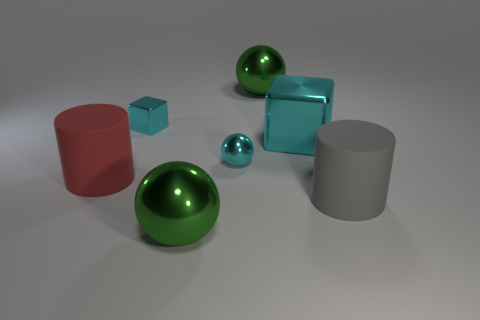What is the material of the large red object that is the same shape as the big gray rubber thing?
Ensure brevity in your answer.  Rubber. There is another cylinder that is the same size as the gray matte cylinder; what is its color?
Offer a terse response. Red. Is the number of tiny shiny things that are in front of the tiny cyan metallic cube the same as the number of tiny cyan cubes?
Make the answer very short. Yes. The matte object that is to the right of the big metallic sphere that is behind the red matte object is what color?
Your response must be concise. Gray. What size is the cyan block that is on the left side of the large block behind the red cylinder?
Offer a terse response. Small. There is a metallic ball that is the same color as the large shiny block; what size is it?
Offer a terse response. Small. What number of other objects are the same size as the red rubber cylinder?
Ensure brevity in your answer.  4. The large rubber object to the right of the big cyan metallic block behind the tiny metallic object that is in front of the tiny cyan cube is what color?
Make the answer very short. Gray. What number of other objects are there of the same shape as the red object?
Make the answer very short. 1. There is a green shiny thing that is in front of the large cyan metal cube; what shape is it?
Your response must be concise. Sphere. 